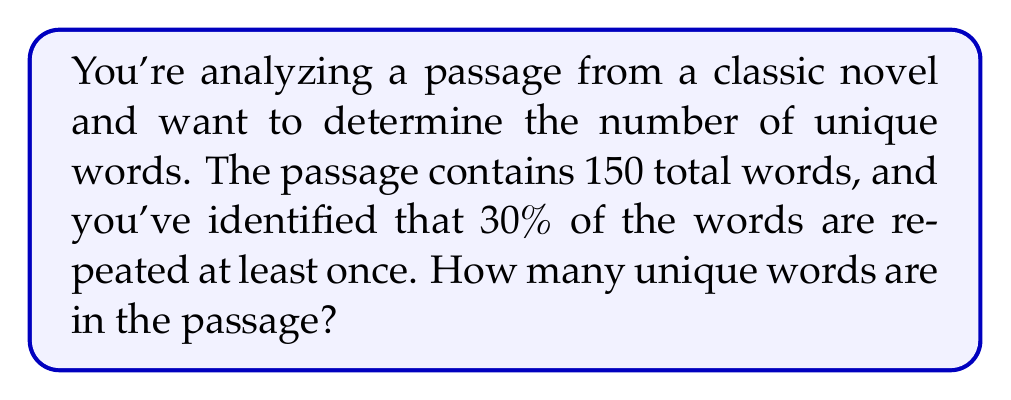What is the answer to this math problem? Let's approach this step-by-step:

1) First, we need to understand what the question is asking:
   - Total words in the passage: 150
   - 30% of words are repeated at least once
   - We need to find the number of unique words

2) Let's define some variables:
   Let $x$ be the number of unique words
   Let $y$ be the number of repeated words

3) We know that the total words is the sum of unique words and repeated words:
   $x + y = 150$

4) We're told that 30% of words are repeated. This means:
   $y = 0.30 \times 150 = 45$

5) Now we can substitute this into our equation from step 3:
   $x + 45 = 150$

6) Solving for $x$:
   $x = 150 - 45 = 105$

Therefore, there are 105 unique words in the passage.
Answer: 105 